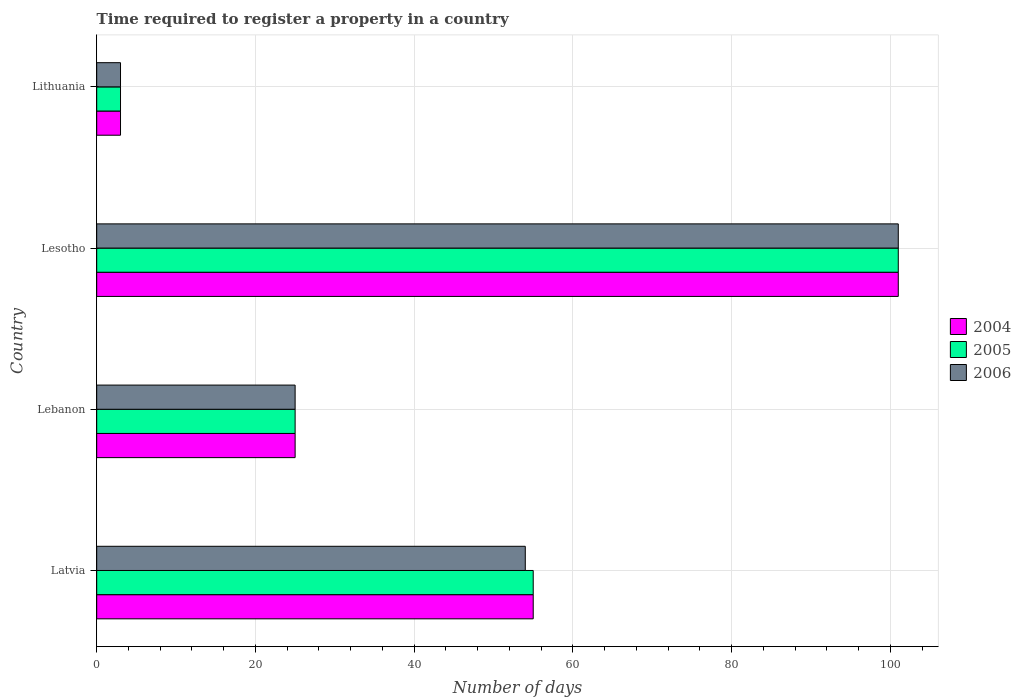Are the number of bars on each tick of the Y-axis equal?
Offer a terse response. Yes. How many bars are there on the 1st tick from the top?
Your answer should be compact. 3. How many bars are there on the 4th tick from the bottom?
Your answer should be very brief. 3. What is the label of the 2nd group of bars from the top?
Provide a short and direct response. Lesotho. What is the number of days required to register a property in 2006 in Lesotho?
Offer a terse response. 101. Across all countries, what is the maximum number of days required to register a property in 2006?
Your answer should be very brief. 101. Across all countries, what is the minimum number of days required to register a property in 2006?
Provide a succinct answer. 3. In which country was the number of days required to register a property in 2005 maximum?
Provide a short and direct response. Lesotho. In which country was the number of days required to register a property in 2005 minimum?
Your answer should be very brief. Lithuania. What is the total number of days required to register a property in 2005 in the graph?
Provide a short and direct response. 184. What is the average number of days required to register a property in 2006 per country?
Make the answer very short. 45.75. What is the difference between the number of days required to register a property in 2006 and number of days required to register a property in 2004 in Lesotho?
Your answer should be very brief. 0. What is the ratio of the number of days required to register a property in 2005 in Latvia to that in Lesotho?
Give a very brief answer. 0.54. Is the difference between the number of days required to register a property in 2006 in Lesotho and Lithuania greater than the difference between the number of days required to register a property in 2004 in Lesotho and Lithuania?
Provide a succinct answer. No. What is the difference between the highest and the second highest number of days required to register a property in 2004?
Offer a very short reply. 46. What is the difference between the highest and the lowest number of days required to register a property in 2004?
Your answer should be compact. 98. Is the sum of the number of days required to register a property in 2005 in Latvia and Lesotho greater than the maximum number of days required to register a property in 2006 across all countries?
Your response must be concise. Yes. What does the 2nd bar from the top in Lebanon represents?
Keep it short and to the point. 2005. What does the 3rd bar from the bottom in Lesotho represents?
Your answer should be compact. 2006. Is it the case that in every country, the sum of the number of days required to register a property in 2006 and number of days required to register a property in 2004 is greater than the number of days required to register a property in 2005?
Your answer should be very brief. Yes. How many countries are there in the graph?
Your answer should be compact. 4. What is the difference between two consecutive major ticks on the X-axis?
Offer a terse response. 20. Are the values on the major ticks of X-axis written in scientific E-notation?
Offer a terse response. No. How many legend labels are there?
Offer a terse response. 3. What is the title of the graph?
Your answer should be compact. Time required to register a property in a country. What is the label or title of the X-axis?
Your answer should be very brief. Number of days. What is the Number of days of 2004 in Latvia?
Keep it short and to the point. 55. What is the Number of days of 2005 in Lebanon?
Offer a very short reply. 25. What is the Number of days in 2006 in Lebanon?
Your answer should be compact. 25. What is the Number of days in 2004 in Lesotho?
Offer a terse response. 101. What is the Number of days of 2005 in Lesotho?
Offer a terse response. 101. What is the Number of days in 2006 in Lesotho?
Keep it short and to the point. 101. What is the Number of days of 2004 in Lithuania?
Your response must be concise. 3. Across all countries, what is the maximum Number of days in 2004?
Offer a very short reply. 101. Across all countries, what is the maximum Number of days of 2005?
Provide a short and direct response. 101. Across all countries, what is the maximum Number of days in 2006?
Your response must be concise. 101. Across all countries, what is the minimum Number of days in 2005?
Ensure brevity in your answer.  3. Across all countries, what is the minimum Number of days of 2006?
Offer a terse response. 3. What is the total Number of days in 2004 in the graph?
Your response must be concise. 184. What is the total Number of days in 2005 in the graph?
Your answer should be compact. 184. What is the total Number of days of 2006 in the graph?
Make the answer very short. 183. What is the difference between the Number of days of 2004 in Latvia and that in Lesotho?
Offer a very short reply. -46. What is the difference between the Number of days in 2005 in Latvia and that in Lesotho?
Ensure brevity in your answer.  -46. What is the difference between the Number of days in 2006 in Latvia and that in Lesotho?
Offer a terse response. -47. What is the difference between the Number of days of 2004 in Latvia and that in Lithuania?
Provide a short and direct response. 52. What is the difference between the Number of days in 2004 in Lebanon and that in Lesotho?
Ensure brevity in your answer.  -76. What is the difference between the Number of days in 2005 in Lebanon and that in Lesotho?
Ensure brevity in your answer.  -76. What is the difference between the Number of days of 2006 in Lebanon and that in Lesotho?
Ensure brevity in your answer.  -76. What is the difference between the Number of days of 2004 in Lebanon and that in Lithuania?
Ensure brevity in your answer.  22. What is the difference between the Number of days of 2005 in Lebanon and that in Lithuania?
Give a very brief answer. 22. What is the difference between the Number of days in 2005 in Latvia and the Number of days in 2006 in Lebanon?
Ensure brevity in your answer.  30. What is the difference between the Number of days of 2004 in Latvia and the Number of days of 2005 in Lesotho?
Offer a terse response. -46. What is the difference between the Number of days in 2004 in Latvia and the Number of days in 2006 in Lesotho?
Ensure brevity in your answer.  -46. What is the difference between the Number of days of 2005 in Latvia and the Number of days of 2006 in Lesotho?
Your answer should be very brief. -46. What is the difference between the Number of days in 2004 in Latvia and the Number of days in 2005 in Lithuania?
Keep it short and to the point. 52. What is the difference between the Number of days in 2004 in Latvia and the Number of days in 2006 in Lithuania?
Make the answer very short. 52. What is the difference between the Number of days of 2005 in Latvia and the Number of days of 2006 in Lithuania?
Offer a very short reply. 52. What is the difference between the Number of days of 2004 in Lebanon and the Number of days of 2005 in Lesotho?
Ensure brevity in your answer.  -76. What is the difference between the Number of days in 2004 in Lebanon and the Number of days in 2006 in Lesotho?
Offer a very short reply. -76. What is the difference between the Number of days in 2005 in Lebanon and the Number of days in 2006 in Lesotho?
Give a very brief answer. -76. What is the difference between the Number of days of 2004 in Lebanon and the Number of days of 2005 in Lithuania?
Your answer should be very brief. 22. What is the difference between the Number of days of 2004 in Lesotho and the Number of days of 2005 in Lithuania?
Provide a short and direct response. 98. What is the difference between the Number of days of 2004 in Lesotho and the Number of days of 2006 in Lithuania?
Provide a short and direct response. 98. What is the difference between the Number of days in 2005 in Lesotho and the Number of days in 2006 in Lithuania?
Offer a very short reply. 98. What is the average Number of days in 2005 per country?
Keep it short and to the point. 46. What is the average Number of days of 2006 per country?
Provide a succinct answer. 45.75. What is the difference between the Number of days of 2004 and Number of days of 2006 in Latvia?
Provide a short and direct response. 1. What is the difference between the Number of days in 2004 and Number of days in 2006 in Lebanon?
Your answer should be compact. 0. What is the difference between the Number of days in 2005 and Number of days in 2006 in Lebanon?
Offer a terse response. 0. What is the difference between the Number of days of 2004 and Number of days of 2006 in Lesotho?
Make the answer very short. 0. What is the difference between the Number of days in 2005 and Number of days in 2006 in Lesotho?
Offer a very short reply. 0. What is the difference between the Number of days of 2004 and Number of days of 2005 in Lithuania?
Your answer should be very brief. 0. What is the ratio of the Number of days in 2006 in Latvia to that in Lebanon?
Make the answer very short. 2.16. What is the ratio of the Number of days in 2004 in Latvia to that in Lesotho?
Give a very brief answer. 0.54. What is the ratio of the Number of days in 2005 in Latvia to that in Lesotho?
Your answer should be compact. 0.54. What is the ratio of the Number of days in 2006 in Latvia to that in Lesotho?
Keep it short and to the point. 0.53. What is the ratio of the Number of days in 2004 in Latvia to that in Lithuania?
Give a very brief answer. 18.33. What is the ratio of the Number of days in 2005 in Latvia to that in Lithuania?
Keep it short and to the point. 18.33. What is the ratio of the Number of days in 2006 in Latvia to that in Lithuania?
Offer a very short reply. 18. What is the ratio of the Number of days in 2004 in Lebanon to that in Lesotho?
Provide a short and direct response. 0.25. What is the ratio of the Number of days of 2005 in Lebanon to that in Lesotho?
Your answer should be very brief. 0.25. What is the ratio of the Number of days in 2006 in Lebanon to that in Lesotho?
Your response must be concise. 0.25. What is the ratio of the Number of days in 2004 in Lebanon to that in Lithuania?
Offer a very short reply. 8.33. What is the ratio of the Number of days of 2005 in Lebanon to that in Lithuania?
Your answer should be very brief. 8.33. What is the ratio of the Number of days of 2006 in Lebanon to that in Lithuania?
Make the answer very short. 8.33. What is the ratio of the Number of days in 2004 in Lesotho to that in Lithuania?
Your answer should be very brief. 33.67. What is the ratio of the Number of days in 2005 in Lesotho to that in Lithuania?
Keep it short and to the point. 33.67. What is the ratio of the Number of days in 2006 in Lesotho to that in Lithuania?
Your response must be concise. 33.67. What is the difference between the highest and the second highest Number of days of 2004?
Ensure brevity in your answer.  46. What is the difference between the highest and the lowest Number of days of 2004?
Offer a terse response. 98. What is the difference between the highest and the lowest Number of days in 2006?
Provide a succinct answer. 98. 